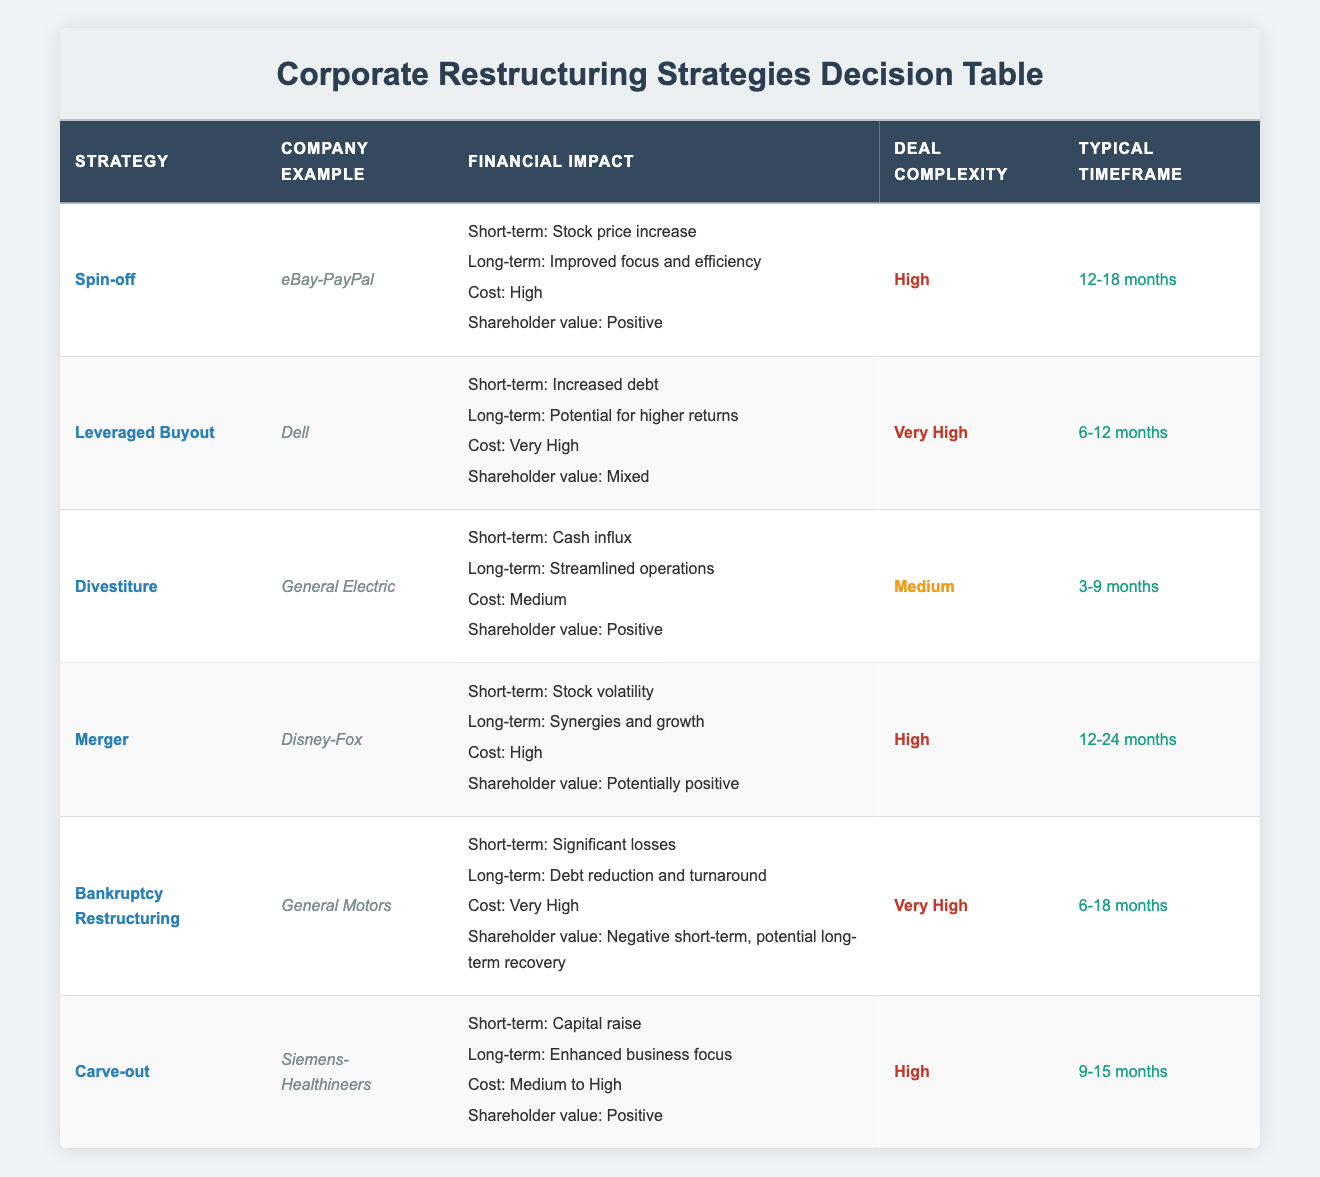What is the strategy used by eBay with PayPal? The table indicates that eBay used the spin-off strategy with PayPal. This is found in the "Company Example" column corresponding to the "Spin-off" strategy.
Answer: Spin-off Which restructuring strategy has a very high cost? The table lists both the leveraged buyout and bankruptcy restructuring strategies as having a very high cost. The "Cost" column for these strategies indicates this.
Answer: Leveraged Buyout, Bankruptcy Restructuring What is the typical timeframe for a divestiture? The divestiture strategy has a typical timeframe of 3-9 months. This information can be found in the corresponding "Typical Timeframe" column for the divestiture row.
Answer: 3-9 months What are the financial impacts of a merger? The merger strategy has various financial impacts: in the short term, it results in stock volatility, and in the long term, it leads to synergies and growth. Additionally, the cost is high and the shareholder value is potentially positive.
Answer: Stock volatility (short-term), synergies and growth (long-term) List the restructuring strategies that have a positive shareholder value. The strategies with positive shareholder value are spin-off, divestiture, and carve-out. This can be determined by reviewing the "Shareholder value" column across the different strategies and selecting those marked positive.
Answer: Spin-off, Divestiture, Carve-out Which strategy has the potential for higher returns in the long term? The leveraged buyout strategy has the potential for higher returns in the long term as stated in its financial impacts section. This is referenced from the "long-term" impact of the leveraged buyout in the table.
Answer: Leveraged Buyout Is the deal complexity for a carve-out higher than that of a divestiture? Yes, the deal complexity for a carve-out is high, while a divestiture is medium. This can be validated by comparing the values in the "Deal Complexity" column for both strategies in the table.
Answer: Yes What is the average cost classification of all listed restructuring strategies? The costs of the strategies are classified as follows: High (Spin-off, Merger), Very High (Leveraged Buyout, Bankruptcy Restructuring), Medium (Divestiture), and Medium to High (Carve-out). To find the average, if we assign values (High=3, Very High=4, Medium=2), the average is (3 + 4 + 2 + 3 + 4 + 3) / 6 = 19 / 6 ≈ 3.17, which falls between high and very high, suggesting a general trend toward higher costs.
Answer: Between high and very high Which restructuring strategy should a company consider for a short-term cash influx? A company should consider the divestiture strategy for a short-term cash influx, as per the financial impact section detailing cash influx as its short-term impact. This is derived from the "Short-term" impact noted under the divestiture strategy.
Answer: Divestiture 